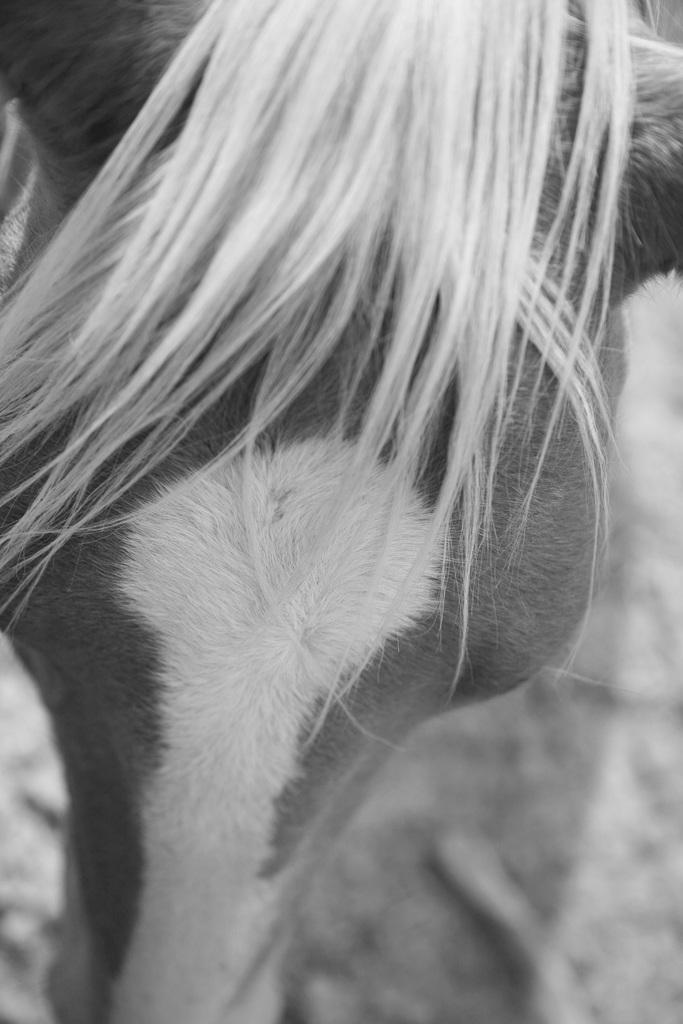What type of living creature is in the image? There is an animal in the image. Where is the animal located? The animal is on the ground. What is a physical characteristic of the animal? The animal has hair. What color scheme is used in the image? The image is in black and white color. Can you tell me how many marbles are in the image? There are no marbles present in the image. What type of man is shown in the image? There is no man present in the image; it features an animal. 